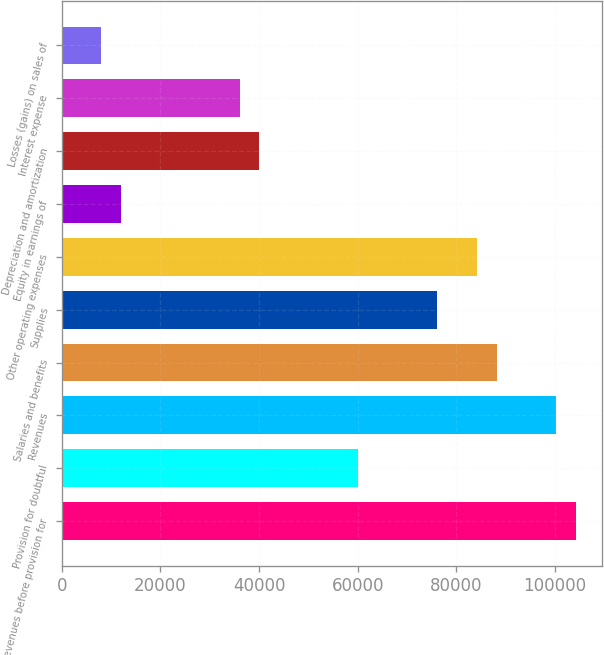Convert chart to OTSL. <chart><loc_0><loc_0><loc_500><loc_500><bar_chart><fcel>Revenues before provision for<fcel>Provision for doubtful<fcel>Revenues<fcel>Salaries and benefits<fcel>Supplies<fcel>Other operating expenses<fcel>Equity in earnings of<fcel>Depreciation and amortization<fcel>Interest expense<fcel>Losses (gains) on sales of<nl><fcel>104219<fcel>60128.4<fcel>100211<fcel>88186.3<fcel>76161.5<fcel>84178<fcel>12029<fcel>40087<fcel>36078.7<fcel>8020.72<nl></chart> 